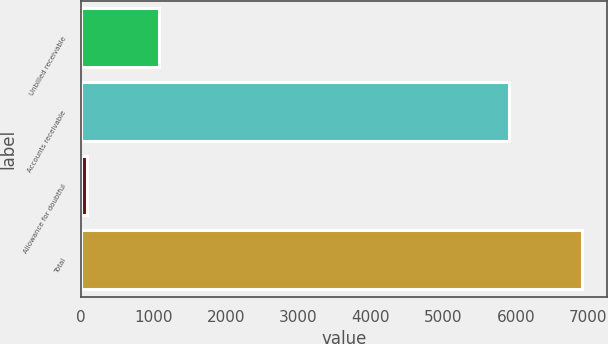Convert chart. <chart><loc_0><loc_0><loc_500><loc_500><bar_chart><fcel>Unbilled receivable<fcel>Accounts receivable<fcel>Allowance for doubtful<fcel>Total<nl><fcel>1086<fcel>5907<fcel>84<fcel>6909<nl></chart> 